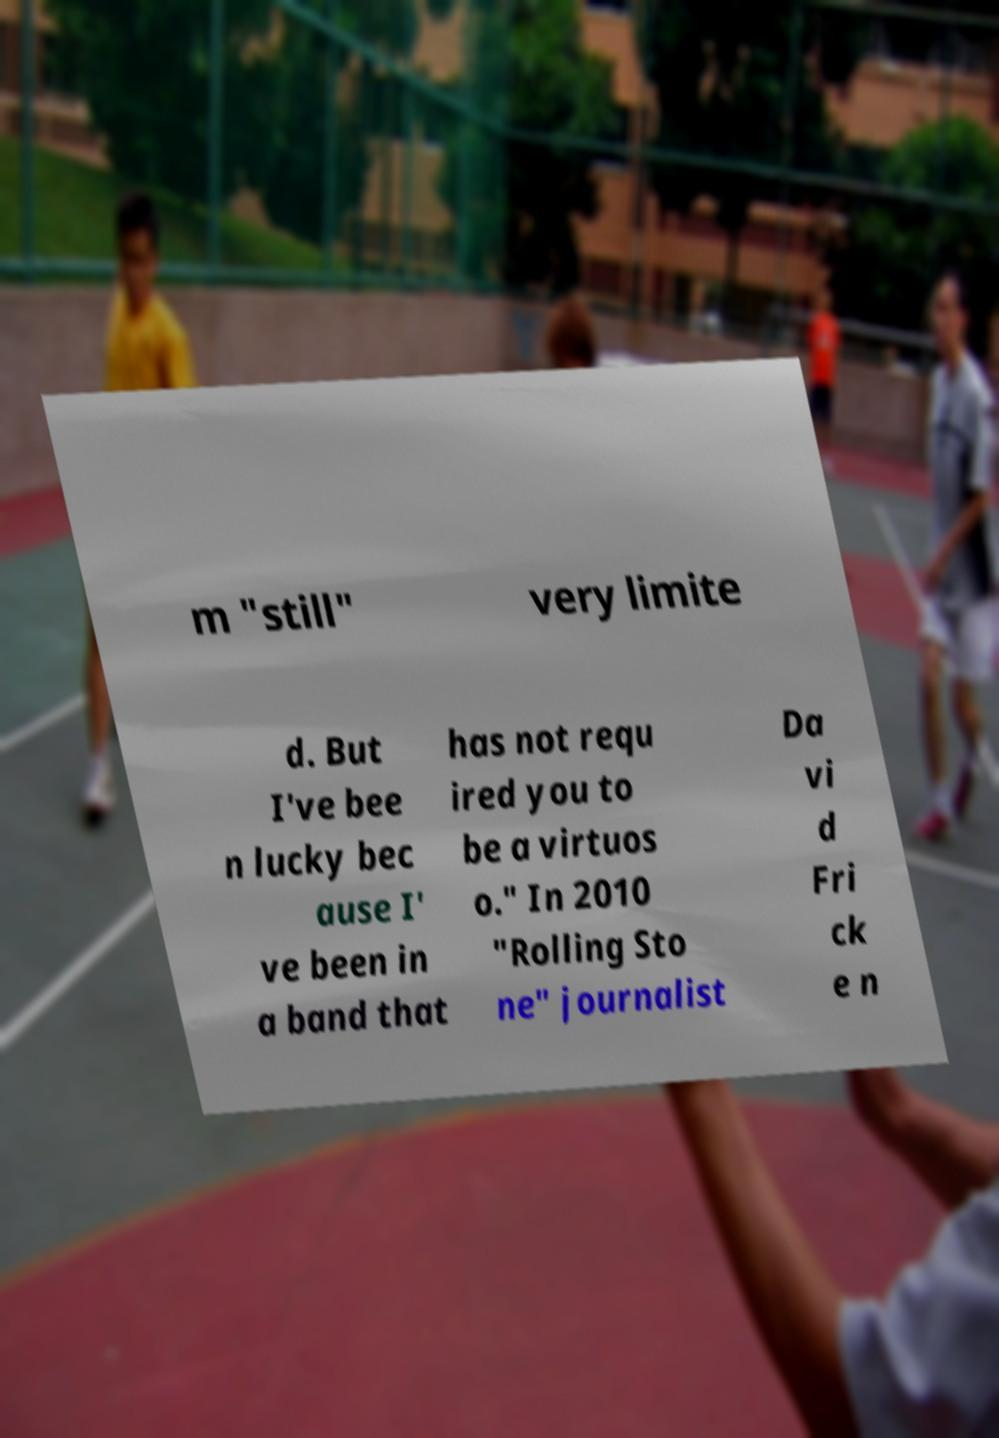There's text embedded in this image that I need extracted. Can you transcribe it verbatim? m "still" very limite d. But I've bee n lucky bec ause I' ve been in a band that has not requ ired you to be a virtuos o." In 2010 "Rolling Sto ne" journalist Da vi d Fri ck e n 